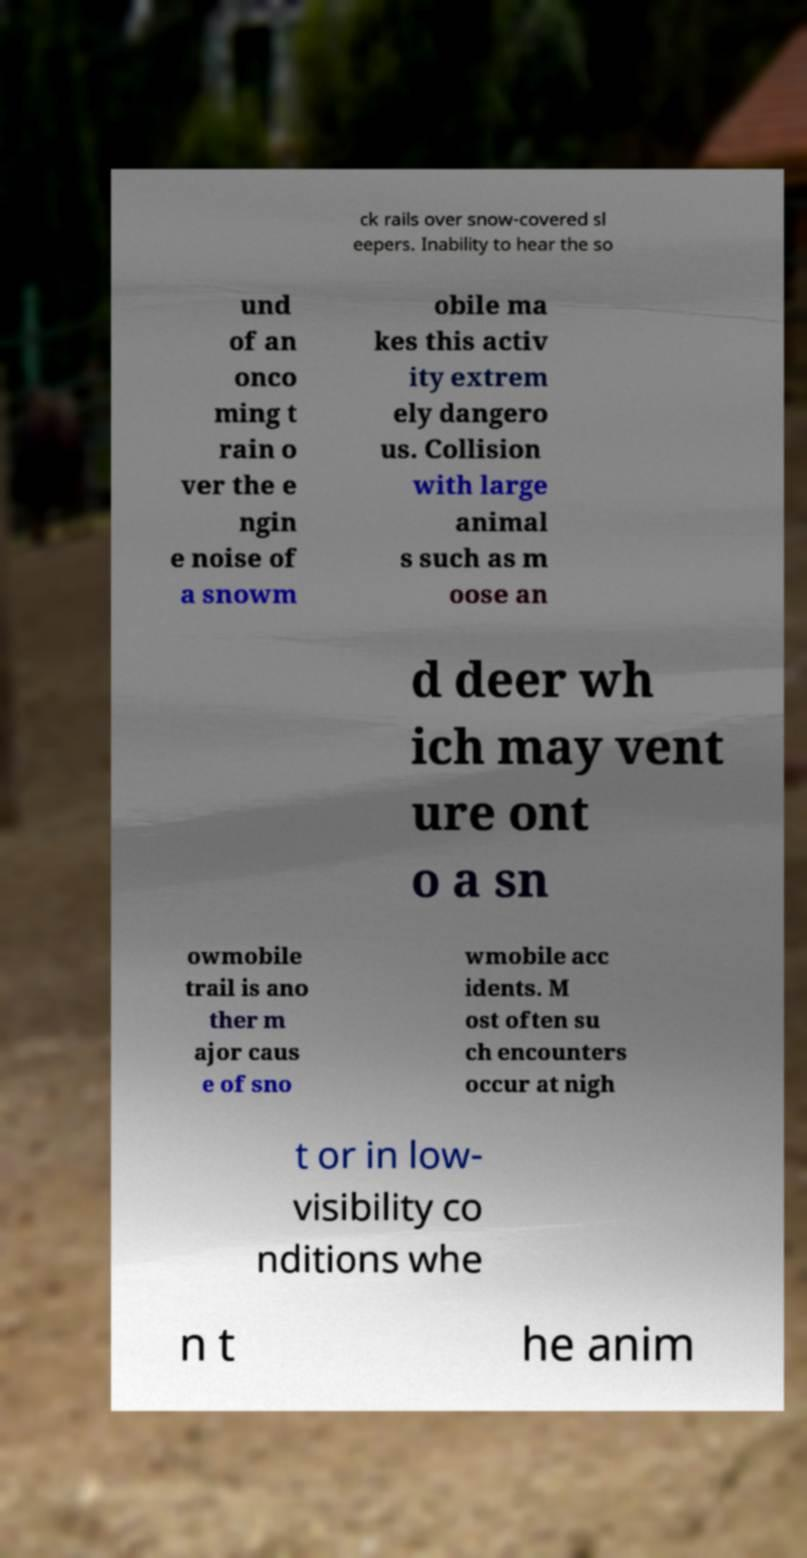There's text embedded in this image that I need extracted. Can you transcribe it verbatim? ck rails over snow-covered sl eepers. Inability to hear the so und of an onco ming t rain o ver the e ngin e noise of a snowm obile ma kes this activ ity extrem ely dangero us. Collision with large animal s such as m oose an d deer wh ich may vent ure ont o a sn owmobile trail is ano ther m ajor caus e of sno wmobile acc idents. M ost often su ch encounters occur at nigh t or in low- visibility co nditions whe n t he anim 